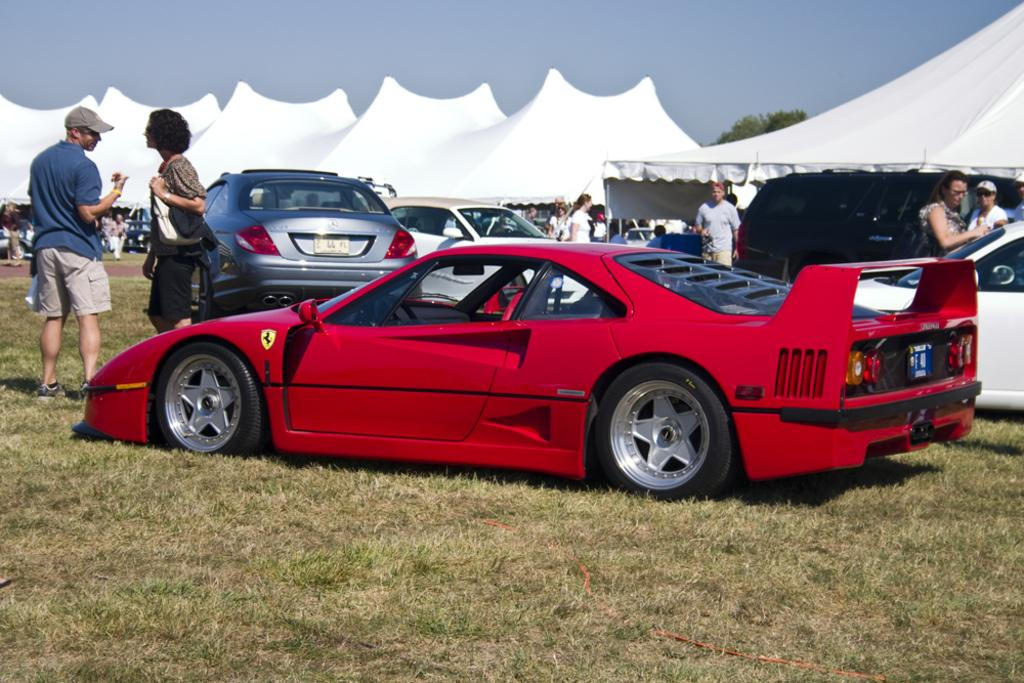What types of objects are present in the image? There are vehicles and people in the image. What can be seen in the background of the image? There are tents, a tree, and the sky visible in the background of the image. What type of cream is being used to cook the stew in the image? There is no cream or stew present in the image; it features vehicles, people, tents, a tree, and the sky. What is the position of the tree in relation to the vehicles in the image? The tree is in the background of the image, and its position relative to the vehicles cannot be determined without more specific information about the scene. 